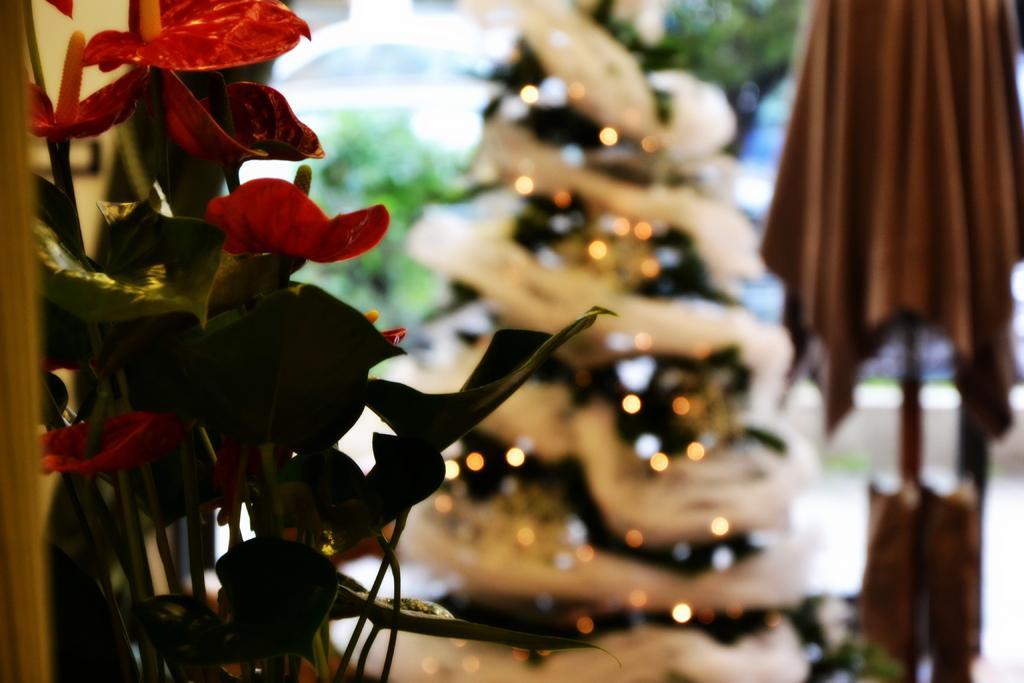In one or two sentences, can you explain what this image depicts? On the left side there is a plant along with the flowers. In the background there is an object which seems to be a Christmas tree. On the right side, I can see a cloth. The background is blurred. 